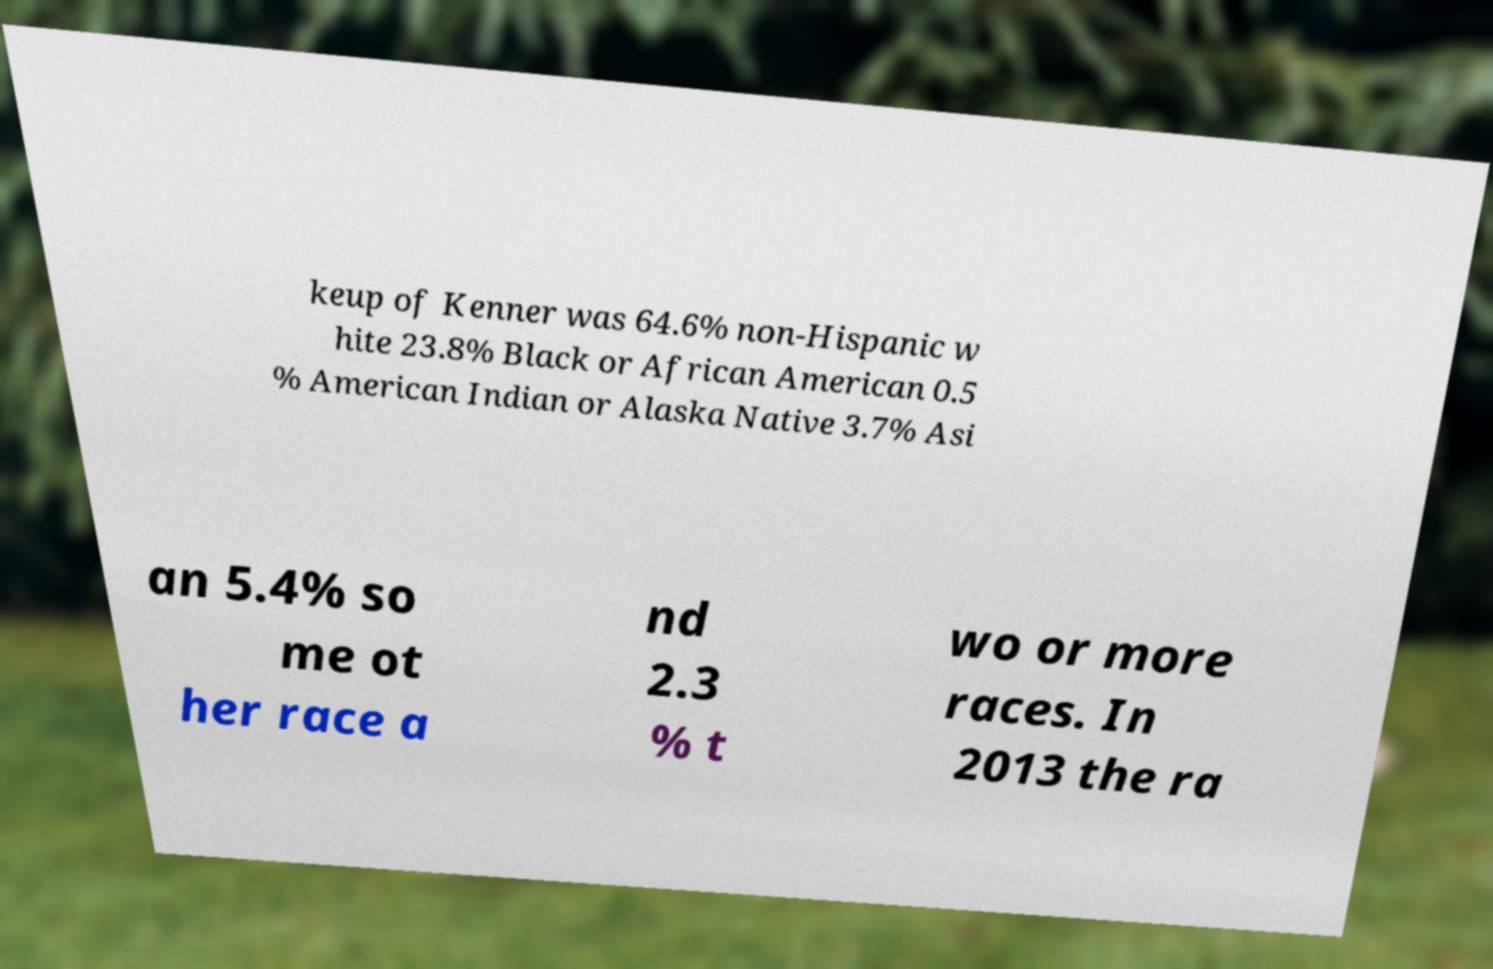There's text embedded in this image that I need extracted. Can you transcribe it verbatim? keup of Kenner was 64.6% non-Hispanic w hite 23.8% Black or African American 0.5 % American Indian or Alaska Native 3.7% Asi an 5.4% so me ot her race a nd 2.3 % t wo or more races. In 2013 the ra 